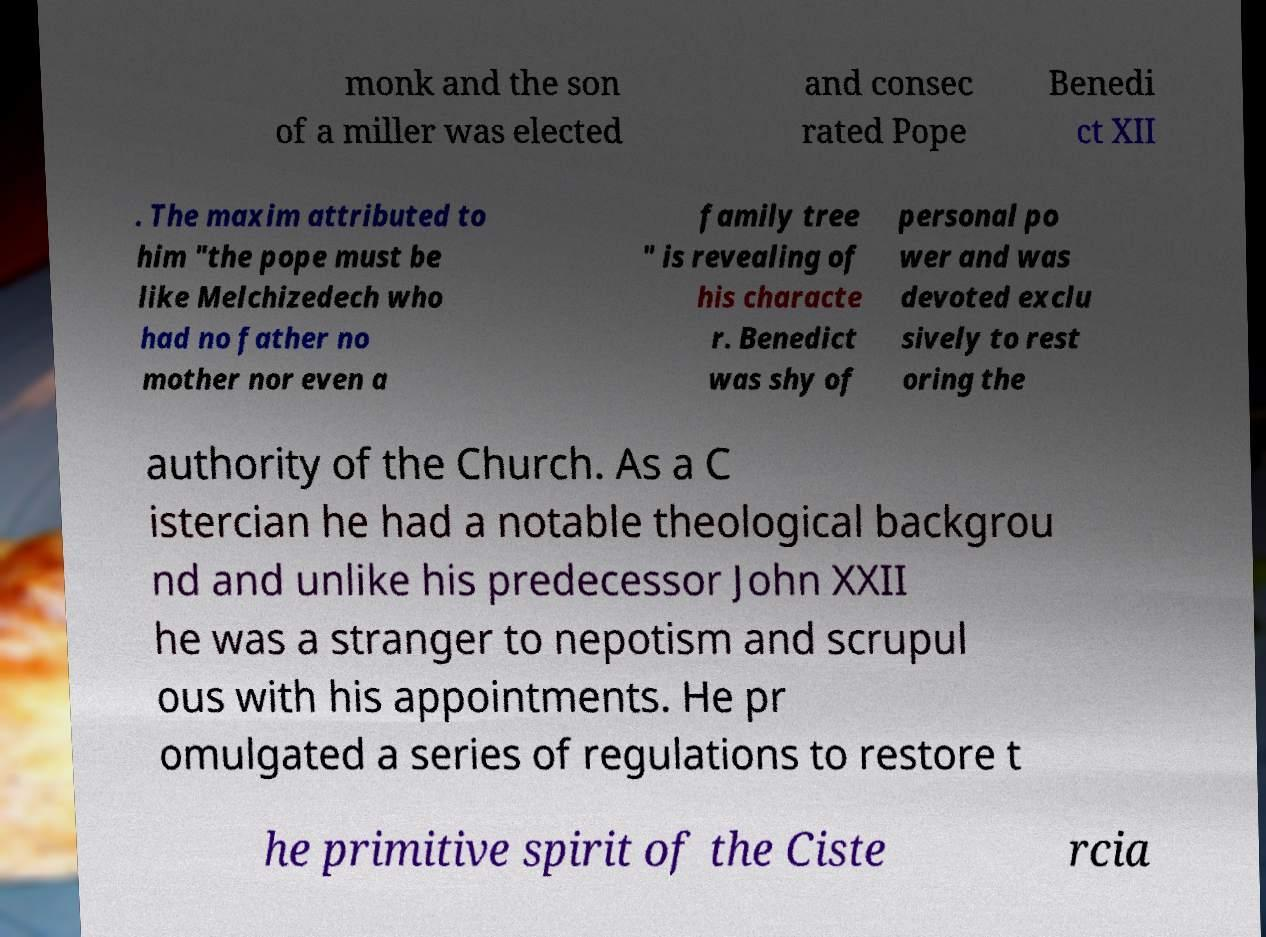There's text embedded in this image that I need extracted. Can you transcribe it verbatim? monk and the son of a miller was elected and consec rated Pope Benedi ct XII . The maxim attributed to him "the pope must be like Melchizedech who had no father no mother nor even a family tree " is revealing of his characte r. Benedict was shy of personal po wer and was devoted exclu sively to rest oring the authority of the Church. As a C istercian he had a notable theological backgrou nd and unlike his predecessor John XXII he was a stranger to nepotism and scrupul ous with his appointments. He pr omulgated a series of regulations to restore t he primitive spirit of the Ciste rcia 